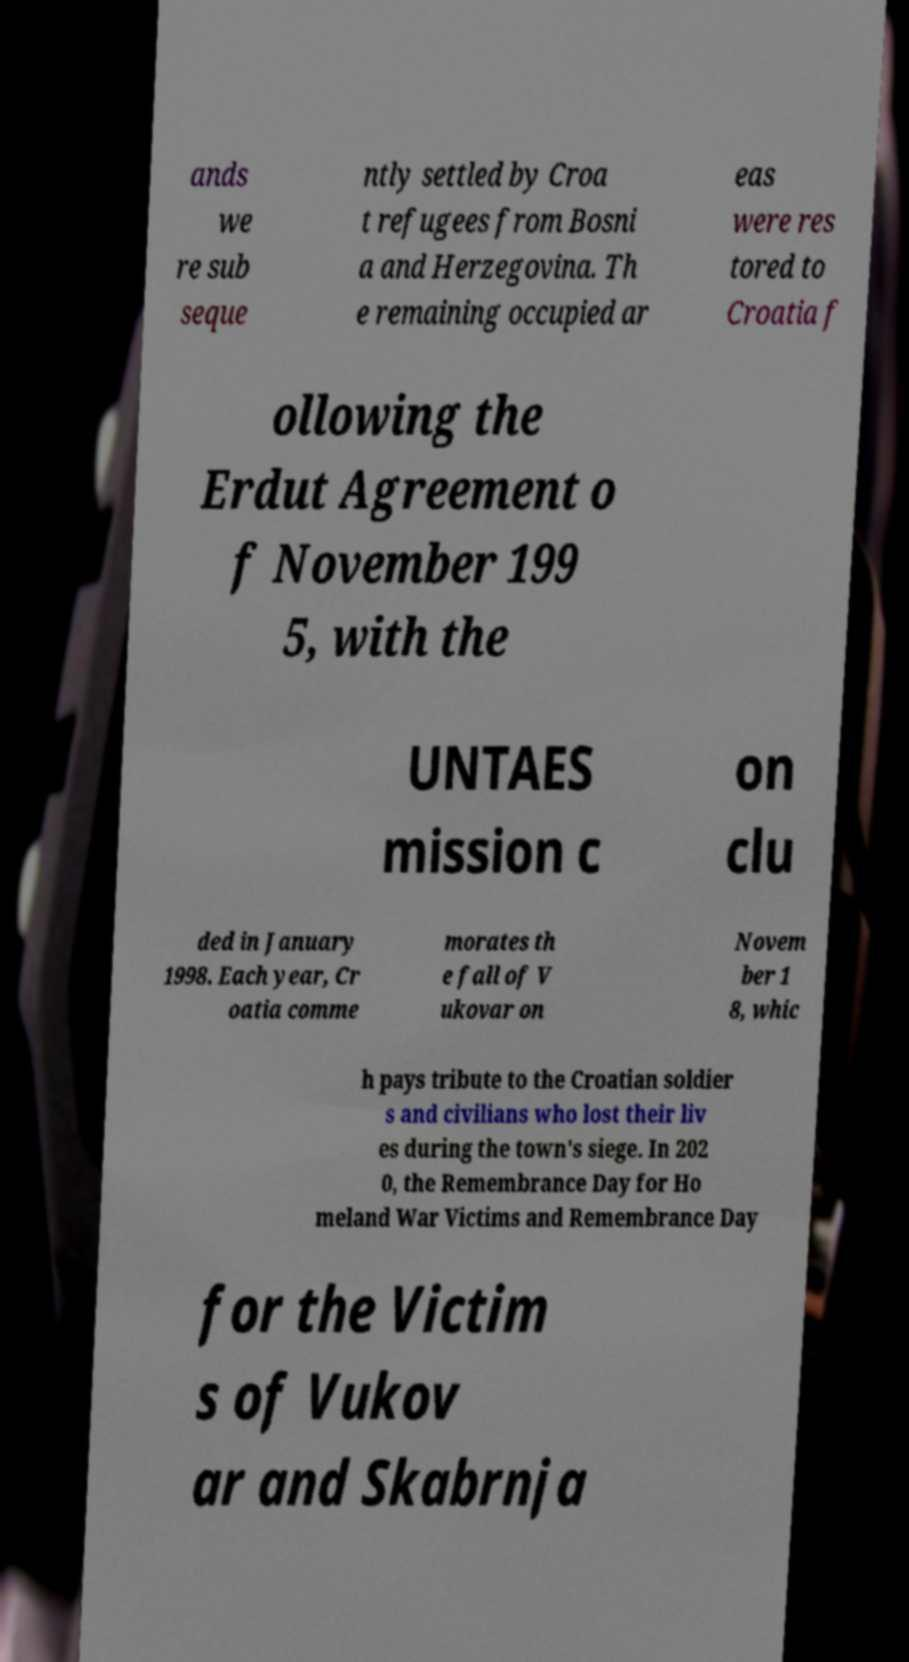There's text embedded in this image that I need extracted. Can you transcribe it verbatim? ands we re sub seque ntly settled by Croa t refugees from Bosni a and Herzegovina. Th e remaining occupied ar eas were res tored to Croatia f ollowing the Erdut Agreement o f November 199 5, with the UNTAES mission c on clu ded in January 1998. Each year, Cr oatia comme morates th e fall of V ukovar on Novem ber 1 8, whic h pays tribute to the Croatian soldier s and civilians who lost their liv es during the town's siege. In 202 0, the Remembrance Day for Ho meland War Victims and Remembrance Day for the Victim s of Vukov ar and Skabrnja 